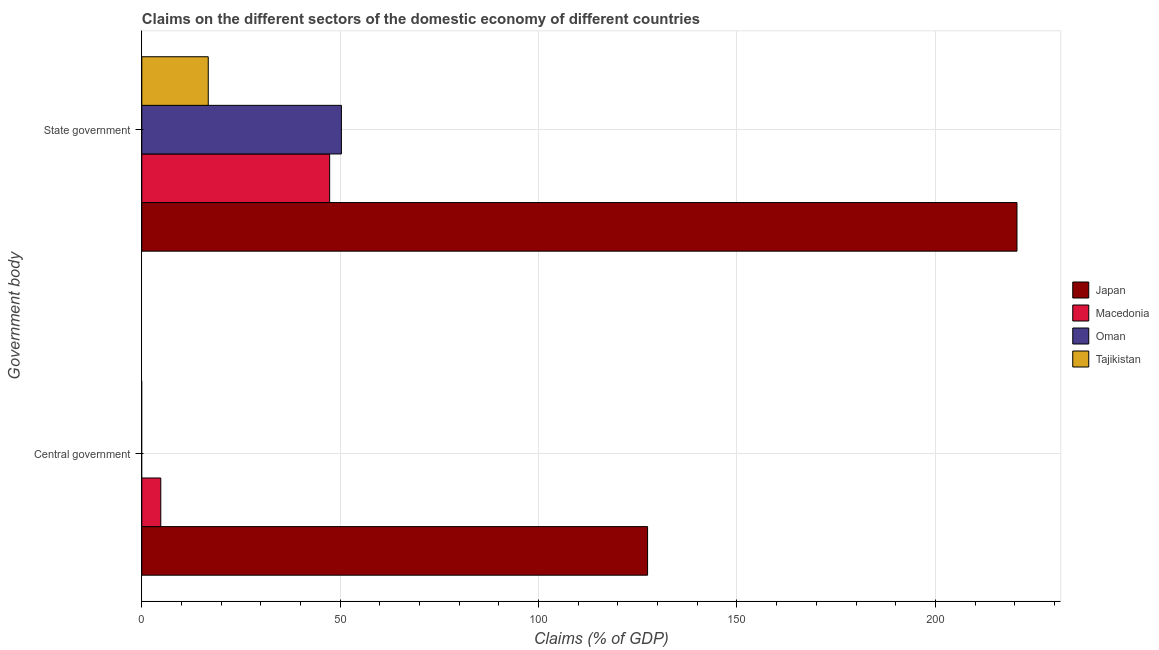How many different coloured bars are there?
Make the answer very short. 4. Are the number of bars per tick equal to the number of legend labels?
Make the answer very short. No. What is the label of the 2nd group of bars from the top?
Provide a short and direct response. Central government. What is the claims on state government in Oman?
Offer a very short reply. 50.31. Across all countries, what is the maximum claims on central government?
Ensure brevity in your answer.  127.47. Across all countries, what is the minimum claims on state government?
Your answer should be very brief. 16.75. What is the total claims on state government in the graph?
Offer a very short reply. 334.97. What is the difference between the claims on state government in Japan and that in Oman?
Keep it short and to the point. 170.27. What is the difference between the claims on state government in Oman and the claims on central government in Japan?
Provide a short and direct response. -77.17. What is the average claims on state government per country?
Provide a succinct answer. 83.74. What is the difference between the claims on central government and claims on state government in Macedonia?
Provide a short and direct response. -42.56. In how many countries, is the claims on central government greater than 50 %?
Your answer should be compact. 1. What is the ratio of the claims on state government in Oman to that in Macedonia?
Your answer should be very brief. 1.06. Is the claims on state government in Tajikistan less than that in Oman?
Your answer should be compact. Yes. How many bars are there?
Give a very brief answer. 6. Are all the bars in the graph horizontal?
Your answer should be very brief. Yes. What is the difference between two consecutive major ticks on the X-axis?
Offer a very short reply. 50. Does the graph contain any zero values?
Give a very brief answer. Yes. What is the title of the graph?
Ensure brevity in your answer.  Claims on the different sectors of the domestic economy of different countries. Does "Sudan" appear as one of the legend labels in the graph?
Offer a terse response. No. What is the label or title of the X-axis?
Offer a very short reply. Claims (% of GDP). What is the label or title of the Y-axis?
Offer a terse response. Government body. What is the Claims (% of GDP) in Japan in Central government?
Your answer should be very brief. 127.47. What is the Claims (% of GDP) of Macedonia in Central government?
Offer a very short reply. 4.79. What is the Claims (% of GDP) in Japan in State government?
Provide a succinct answer. 220.57. What is the Claims (% of GDP) of Macedonia in State government?
Provide a succinct answer. 47.35. What is the Claims (% of GDP) in Oman in State government?
Your answer should be compact. 50.31. What is the Claims (% of GDP) of Tajikistan in State government?
Give a very brief answer. 16.75. Across all Government body, what is the maximum Claims (% of GDP) of Japan?
Give a very brief answer. 220.57. Across all Government body, what is the maximum Claims (% of GDP) of Macedonia?
Make the answer very short. 47.35. Across all Government body, what is the maximum Claims (% of GDP) in Oman?
Provide a short and direct response. 50.31. Across all Government body, what is the maximum Claims (% of GDP) of Tajikistan?
Offer a very short reply. 16.75. Across all Government body, what is the minimum Claims (% of GDP) of Japan?
Offer a terse response. 127.47. Across all Government body, what is the minimum Claims (% of GDP) of Macedonia?
Your response must be concise. 4.79. What is the total Claims (% of GDP) of Japan in the graph?
Ensure brevity in your answer.  348.05. What is the total Claims (% of GDP) of Macedonia in the graph?
Your answer should be compact. 52.13. What is the total Claims (% of GDP) of Oman in the graph?
Give a very brief answer. 50.31. What is the total Claims (% of GDP) in Tajikistan in the graph?
Your answer should be very brief. 16.75. What is the difference between the Claims (% of GDP) in Japan in Central government and that in State government?
Your answer should be compact. -93.1. What is the difference between the Claims (% of GDP) of Macedonia in Central government and that in State government?
Offer a very short reply. -42.56. What is the difference between the Claims (% of GDP) of Japan in Central government and the Claims (% of GDP) of Macedonia in State government?
Your answer should be very brief. 80.13. What is the difference between the Claims (% of GDP) of Japan in Central government and the Claims (% of GDP) of Oman in State government?
Your response must be concise. 77.17. What is the difference between the Claims (% of GDP) of Japan in Central government and the Claims (% of GDP) of Tajikistan in State government?
Your answer should be very brief. 110.73. What is the difference between the Claims (% of GDP) of Macedonia in Central government and the Claims (% of GDP) of Oman in State government?
Make the answer very short. -45.52. What is the difference between the Claims (% of GDP) in Macedonia in Central government and the Claims (% of GDP) in Tajikistan in State government?
Give a very brief answer. -11.96. What is the average Claims (% of GDP) of Japan per Government body?
Offer a terse response. 174.02. What is the average Claims (% of GDP) in Macedonia per Government body?
Offer a very short reply. 26.07. What is the average Claims (% of GDP) in Oman per Government body?
Your response must be concise. 25.15. What is the average Claims (% of GDP) of Tajikistan per Government body?
Ensure brevity in your answer.  8.37. What is the difference between the Claims (% of GDP) in Japan and Claims (% of GDP) in Macedonia in Central government?
Your response must be concise. 122.69. What is the difference between the Claims (% of GDP) of Japan and Claims (% of GDP) of Macedonia in State government?
Your response must be concise. 173.23. What is the difference between the Claims (% of GDP) of Japan and Claims (% of GDP) of Oman in State government?
Your answer should be compact. 170.27. What is the difference between the Claims (% of GDP) in Japan and Claims (% of GDP) in Tajikistan in State government?
Ensure brevity in your answer.  203.83. What is the difference between the Claims (% of GDP) in Macedonia and Claims (% of GDP) in Oman in State government?
Make the answer very short. -2.96. What is the difference between the Claims (% of GDP) in Macedonia and Claims (% of GDP) in Tajikistan in State government?
Keep it short and to the point. 30.6. What is the difference between the Claims (% of GDP) of Oman and Claims (% of GDP) of Tajikistan in State government?
Provide a short and direct response. 33.56. What is the ratio of the Claims (% of GDP) of Japan in Central government to that in State government?
Make the answer very short. 0.58. What is the ratio of the Claims (% of GDP) in Macedonia in Central government to that in State government?
Provide a short and direct response. 0.1. What is the difference between the highest and the second highest Claims (% of GDP) of Japan?
Your response must be concise. 93.1. What is the difference between the highest and the second highest Claims (% of GDP) of Macedonia?
Your response must be concise. 42.56. What is the difference between the highest and the lowest Claims (% of GDP) in Japan?
Offer a very short reply. 93.1. What is the difference between the highest and the lowest Claims (% of GDP) of Macedonia?
Ensure brevity in your answer.  42.56. What is the difference between the highest and the lowest Claims (% of GDP) in Oman?
Make the answer very short. 50.31. What is the difference between the highest and the lowest Claims (% of GDP) in Tajikistan?
Your response must be concise. 16.75. 